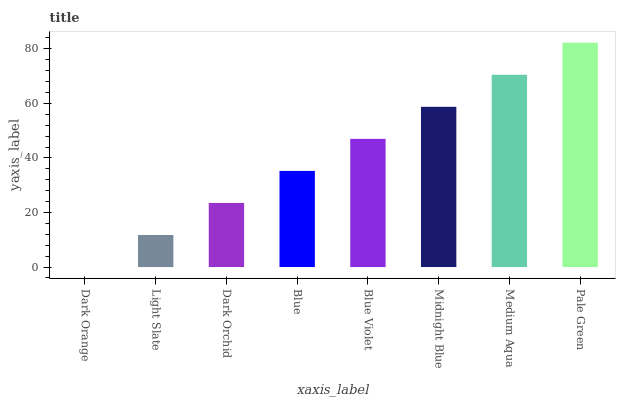Is Dark Orange the minimum?
Answer yes or no. Yes. Is Pale Green the maximum?
Answer yes or no. Yes. Is Light Slate the minimum?
Answer yes or no. No. Is Light Slate the maximum?
Answer yes or no. No. Is Light Slate greater than Dark Orange?
Answer yes or no. Yes. Is Dark Orange less than Light Slate?
Answer yes or no. Yes. Is Dark Orange greater than Light Slate?
Answer yes or no. No. Is Light Slate less than Dark Orange?
Answer yes or no. No. Is Blue Violet the high median?
Answer yes or no. Yes. Is Blue the low median?
Answer yes or no. Yes. Is Medium Aqua the high median?
Answer yes or no. No. Is Pale Green the low median?
Answer yes or no. No. 